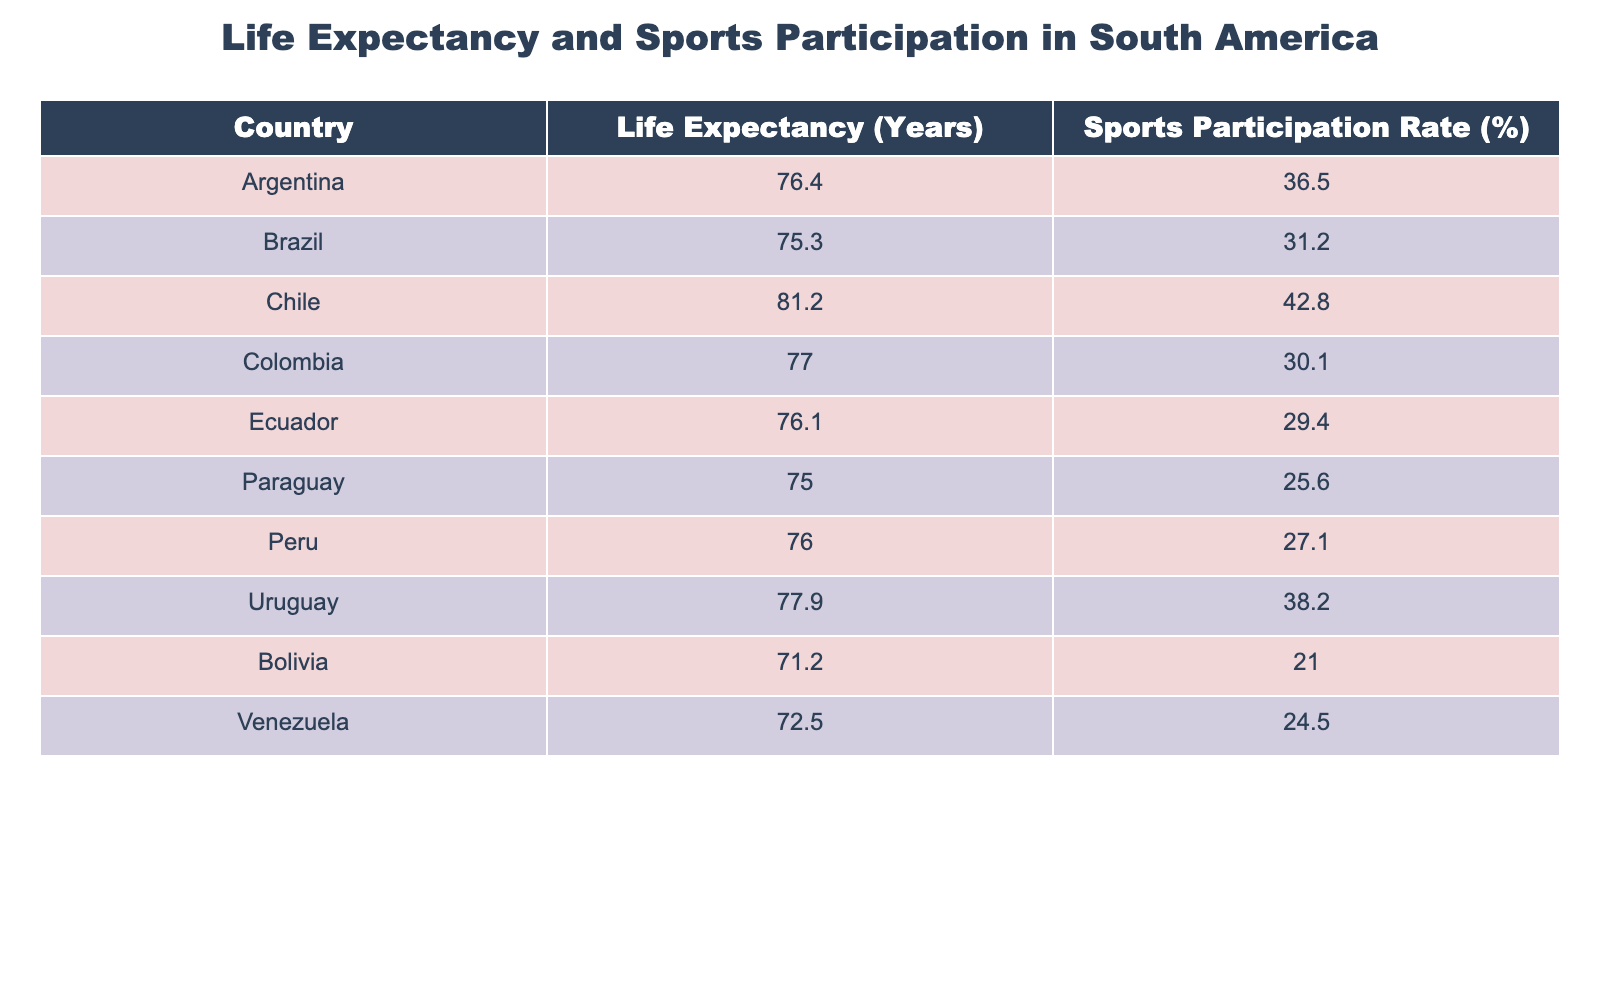What is the life expectancy of Bolivia? According to the table, Bolivia has a life expectancy of 71.2 years, which is directly stated in the column labeled "Life Expectancy (Years)".
Answer: 71.2 years Which country has the highest sports participation rate? From the table, Chile has the highest sports participation rate at 42.8%, shown in the "Sports Participation Rate (%)" column.
Answer: Chile What is the difference in life expectancy between Uruguay and Paraguay? Uruguay has a life expectancy of 77.9 years, and Paraguay's life expectancy is 75.0 years. The difference is calculated as 77.9 - 75.0 = 2.9 years.
Answer: 2.9 years Is the life expectancy in Bolivia lower than that in Venezuela? The life expectancy in Bolivia is 71.2 years, while in Venezuela it is 72.5 years. Since 71.2 is less than 72.5, the statement is true.
Answer: Yes What is the average life expectancy of the countries listed in the table? To find the average, sum the life expectancies of all countries: 76.4 + 75.3 + 81.2 + 77.0 + 76.1 + 75.0 + 76.0 + 77.9 + 71.2 + 72.5 =  76.3 years. There are 10 countries total, so 763.1/10 gives an average of 76.31 years.
Answer: 76.31 years Which country has the lowest sports participation rate? From the data, Paraguay has the lowest sports participation rate at 25.6%, which is evident in the "Sports Participation Rate (%)" column.
Answer: Paraguay If the average sports participation rate of the countries listed is calculated, what would that be? To find the average sports participation rates, sum them: 36.5 + 31.2 + 42.8 + 30.1 + 29.4 + 25.6 + 27.1 + 38.2 + 21.0 + 24.5 =  36.88%, then divide by the total number of countries (10), which gives an average of 36.88%.
Answer: 36.88% Does Ecuador have a higher life expectancy than Colombia? Ecuador's life expectancy is 76.1 years, while Colombia's is 77.0 years. Since 76.1 is less than 77.0, this statement is false.
Answer: No What is the combined life expectancy of Argentina and Brazil? The life expectancy of Argentina is 76.4 years and Brazil is 75.3 years. Adding them gives 76.4 + 75.3 = 151.7 years as the combined life expectancy.
Answer: 151.7 years 